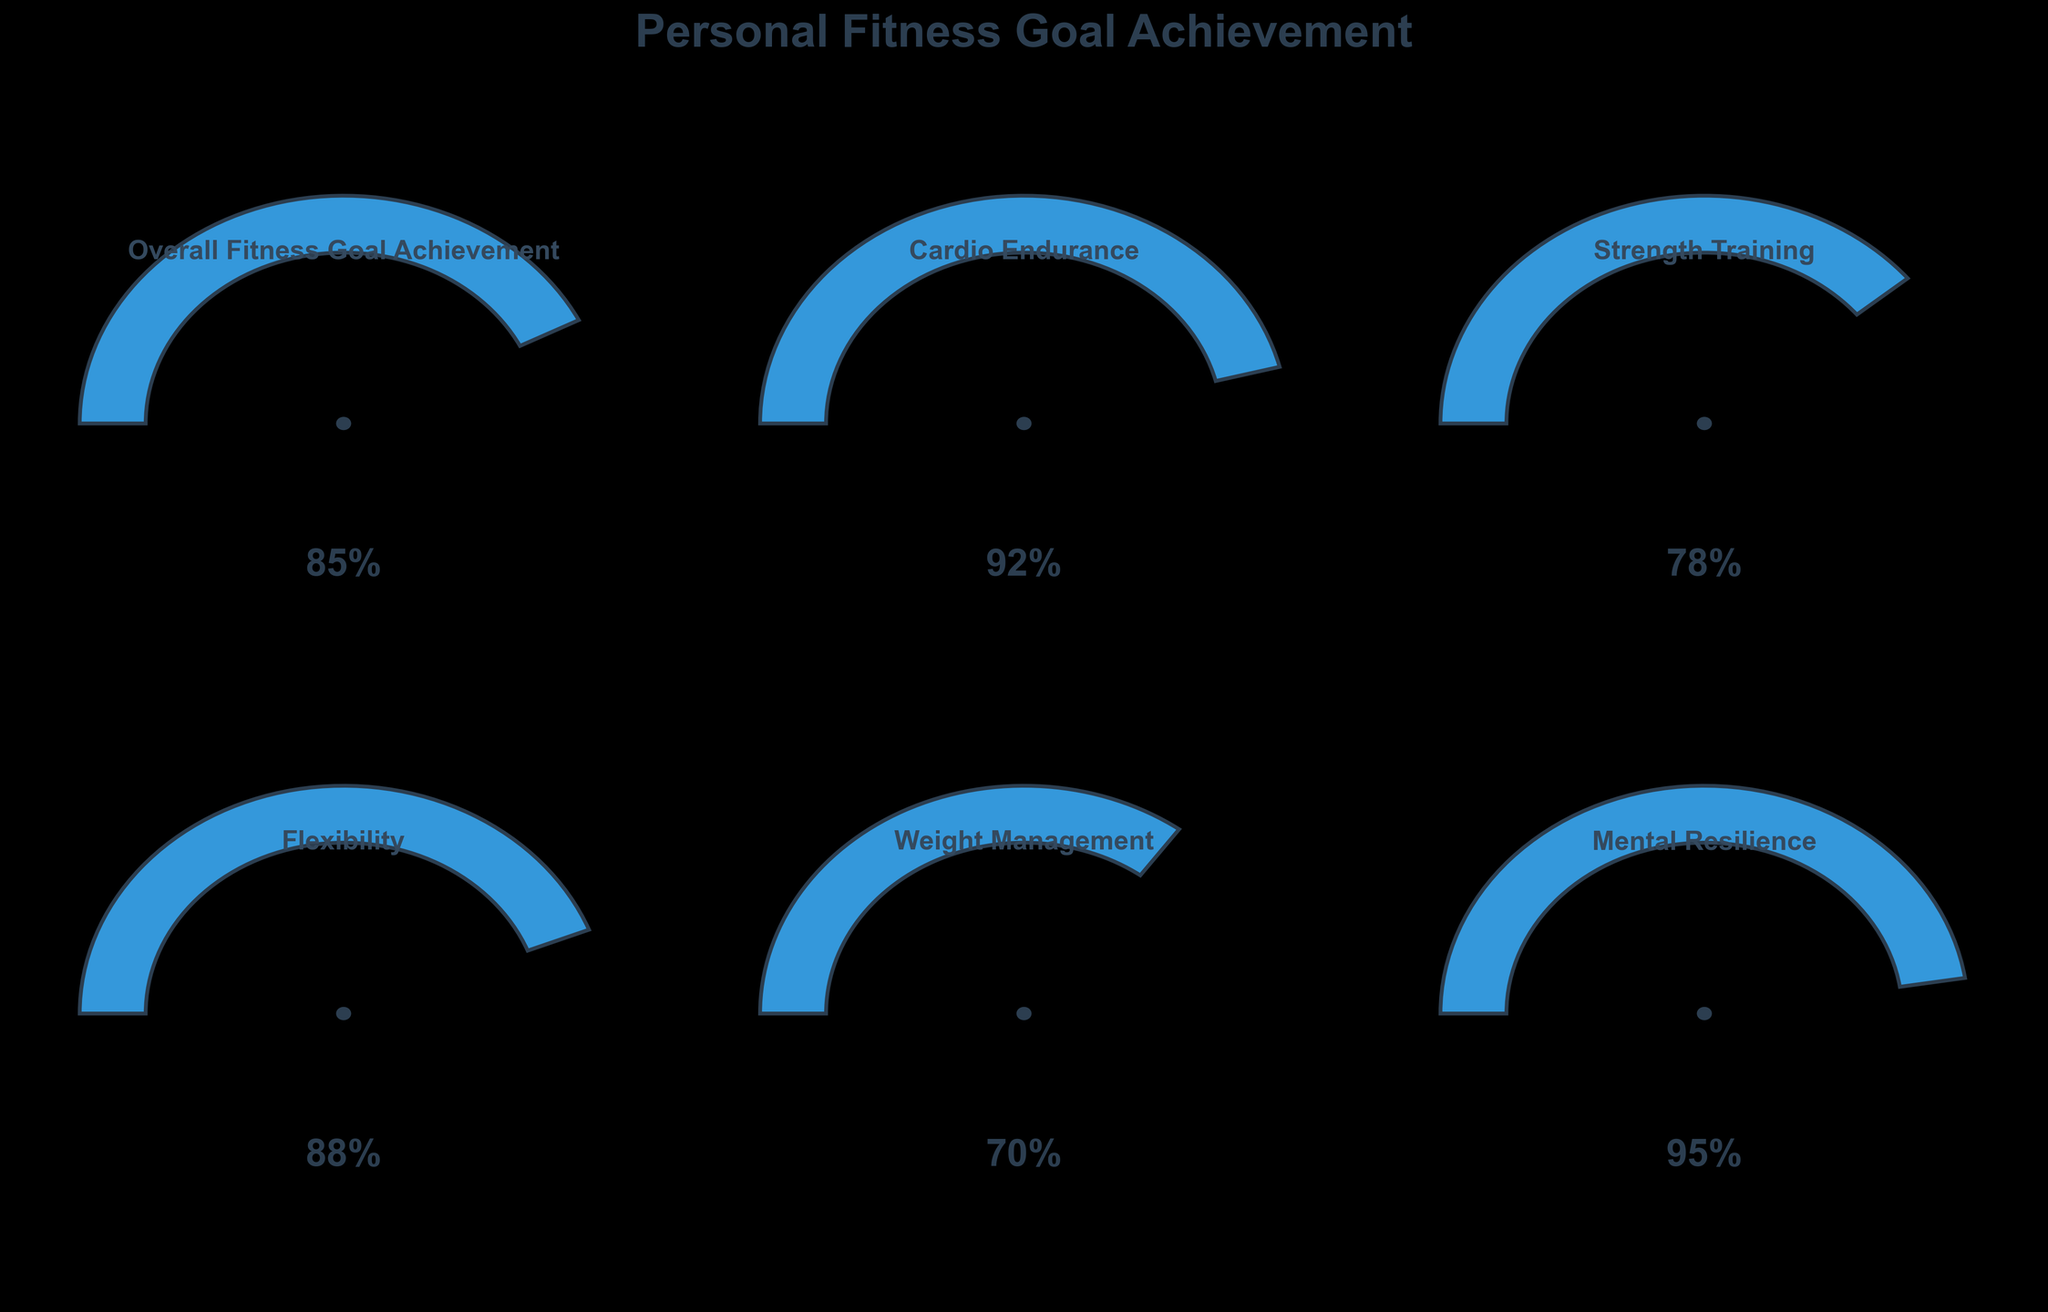what is the value for Cardio Endurance? The value for Cardio Endurance is directly shown in the gauge chart labeled "Cardio Endurance". In this chart, the value is indicated as 92%
Answer: 92% How many gauges are displayed in the figure? By counting the number of gauge charts displayed in the figure, we find there are six gauges in total: Overall Fitness Goal Achievement, Cardio Endurance, Strength Training, Flexibility, Weight Management, and Mental Resilience.
Answer: 6 Which fitness category has the highest value? To find the category with the highest value, compare all the percentages in the gauge charts. The highest value among them is in the "Mental Resilience" category with 95%.
Answer: Mental Resilience Which category has the lowest fitness goal achievement? By comparing the percentages in each gauge chart, the category with the lowest value is "Weight Management" with 70%.
Answer: Weight Management What is the difference between the highest and lowest values in the charts? The highest value in the charts is for Mental Resilience (95%), and the lowest value is for Weight Management (70%). The difference between these two values is 95% - 70% = 25%.
Answer: 25% What is the average value of all the fitness categories? Sum the values of all categories and divide by the number of categories. The values are 85 + 92 + 78 + 88 + 70 + 95 = 508. There are 6 categories, thus the average is 508/6 = 84.67%.
Answer: 84.67% How does the Overall Fitness Goal Achievement compare to Flexibility? The value for Overall Fitness Goal Achievement is 85%, and for Flexibility, it is 88%. Comparing these values, Flexibility (88%) is greater than Overall Fitness Goal Achievement (85%).
Answer: Flexibility is greater What is the median value of all the fitness goal percentages shown in the figure? To find the median, list the values in ascending order: 70, 78, 85, 88, 92, 95. Since there are 6 values, the median is the average of the 3rd and 4th values: (85 + 88) / 2 = 86.5%.
Answer: 86.5% Is the value for Strength Training above or below the overall average of the other categories? The average value of the other categories can be calculated by excluding the Strength Training value and averaging the rest. The other values are 85, 92, 88, 70, and 95, summing to 430. The average is 430/5 = 86%. The value for Strength Training is 78%, which is below this average.
Answer: Below Based on the chart, which three categories have the top values? By comparing the percentages, the three categories with the highest values are Mental Resilience (95%), Cardio Endurance (92%), and Flexibility (88%).
Answer: Mental Resilience, Cardio Endurance, Flexibility 